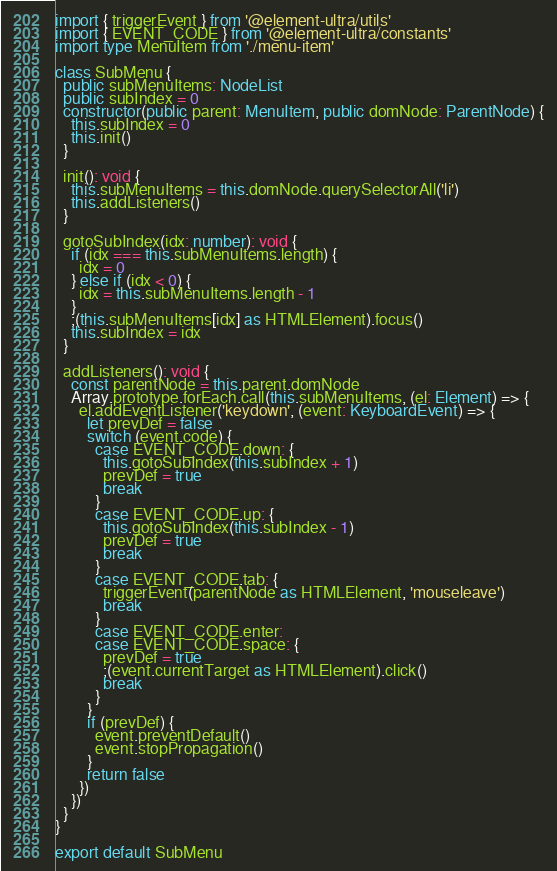Convert code to text. <code><loc_0><loc_0><loc_500><loc_500><_TypeScript_>import { triggerEvent } from '@element-ultra/utils'
import { EVENT_CODE } from '@element-ultra/constants'
import type MenuItem from './menu-item'

class SubMenu {
  public subMenuItems: NodeList
  public subIndex = 0
  constructor(public parent: MenuItem, public domNode: ParentNode) {
    this.subIndex = 0
    this.init()
  }

  init(): void {
    this.subMenuItems = this.domNode.querySelectorAll('li')
    this.addListeners()
  }

  gotoSubIndex(idx: number): void {
    if (idx === this.subMenuItems.length) {
      idx = 0
    } else if (idx < 0) {
      idx = this.subMenuItems.length - 1
    }
    ;(this.subMenuItems[idx] as HTMLElement).focus()
    this.subIndex = idx
  }

  addListeners(): void {
    const parentNode = this.parent.domNode
    Array.prototype.forEach.call(this.subMenuItems, (el: Element) => {
      el.addEventListener('keydown', (event: KeyboardEvent) => {
        let prevDef = false
        switch (event.code) {
          case EVENT_CODE.down: {
            this.gotoSubIndex(this.subIndex + 1)
            prevDef = true
            break
          }
          case EVENT_CODE.up: {
            this.gotoSubIndex(this.subIndex - 1)
            prevDef = true
            break
          }
          case EVENT_CODE.tab: {
            triggerEvent(parentNode as HTMLElement, 'mouseleave')
            break
          }
          case EVENT_CODE.enter:
          case EVENT_CODE.space: {
            prevDef = true
            ;(event.currentTarget as HTMLElement).click()
            break
          }
        }
        if (prevDef) {
          event.preventDefault()
          event.stopPropagation()
        }
        return false
      })
    })
  }
}

export default SubMenu
</code> 